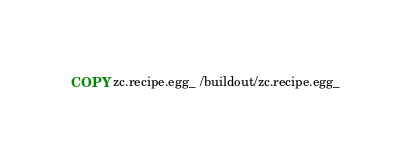Convert code to text. <code><loc_0><loc_0><loc_500><loc_500><_Dockerfile_>COPY zc.recipe.egg_ /buildout/zc.recipe.egg_</code> 